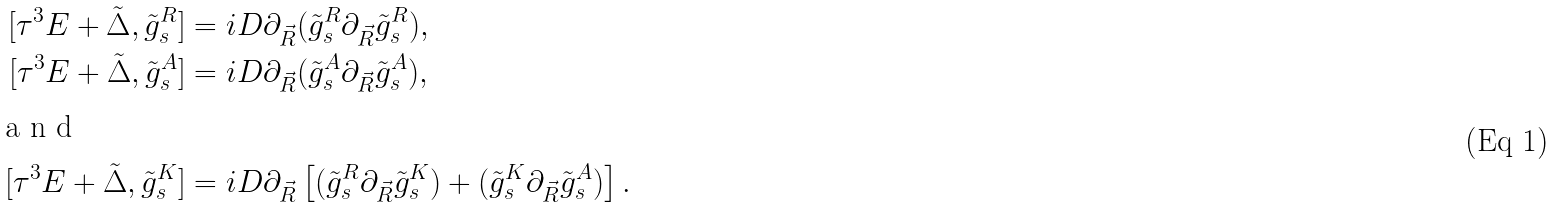<formula> <loc_0><loc_0><loc_500><loc_500>[ \tau ^ { 3 } E + \tilde { \Delta } , \tilde { g } _ { s } ^ { R } ] & = i D \partial _ { \vec { R } } ( \tilde { g } _ { s } ^ { R } \partial _ { \vec { R } } \tilde { g } _ { s } ^ { R } ) , \\ [ \tau ^ { 3 } E + \tilde { \Delta } , \tilde { g } _ { s } ^ { A } ] & = i D \partial _ { \vec { R } } ( \tilde { g } _ { s } ^ { A } \partial _ { \vec { R } } \tilde { g } _ { s } ^ { A } ) , \\ \intertext { a n d } [ \tau ^ { 3 } E + \tilde { \Delta } , \tilde { g } _ { s } ^ { K } ] & = i D \partial _ { \vec { R } } \left [ ( \tilde { g } _ { s } ^ { R } \partial _ { \vec { R } } \tilde { g } _ { s } ^ { K } ) + ( \tilde { g } _ { s } ^ { K } \partial _ { \vec { R } } \tilde { g } _ { s } ^ { A } ) \right ] .</formula> 